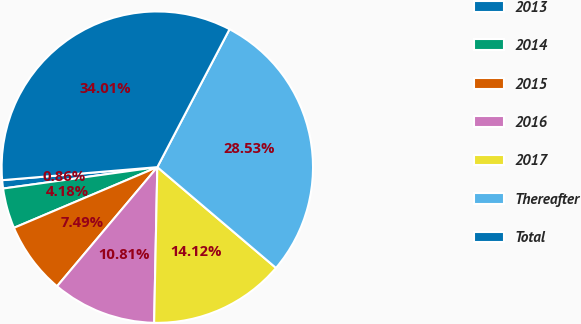Convert chart to OTSL. <chart><loc_0><loc_0><loc_500><loc_500><pie_chart><fcel>2013<fcel>2014<fcel>2015<fcel>2016<fcel>2017<fcel>Thereafter<fcel>Total<nl><fcel>0.86%<fcel>4.18%<fcel>7.49%<fcel>10.81%<fcel>14.12%<fcel>28.53%<fcel>34.01%<nl></chart> 